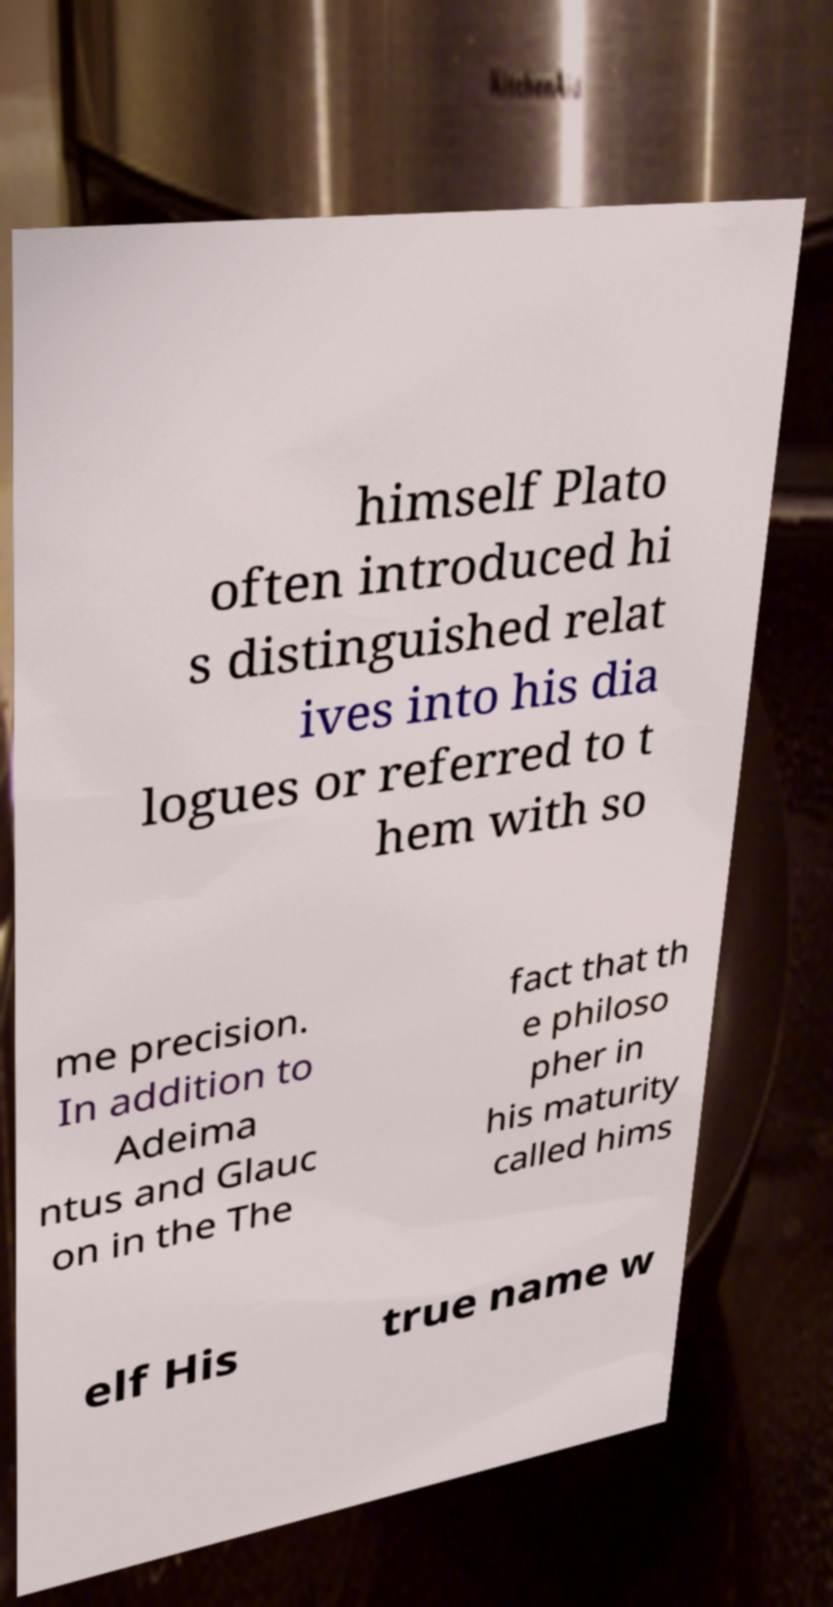Can you accurately transcribe the text from the provided image for me? himself Plato often introduced hi s distinguished relat ives into his dia logues or referred to t hem with so me precision. In addition to Adeima ntus and Glauc on in the The fact that th e philoso pher in his maturity called hims elf His true name w 